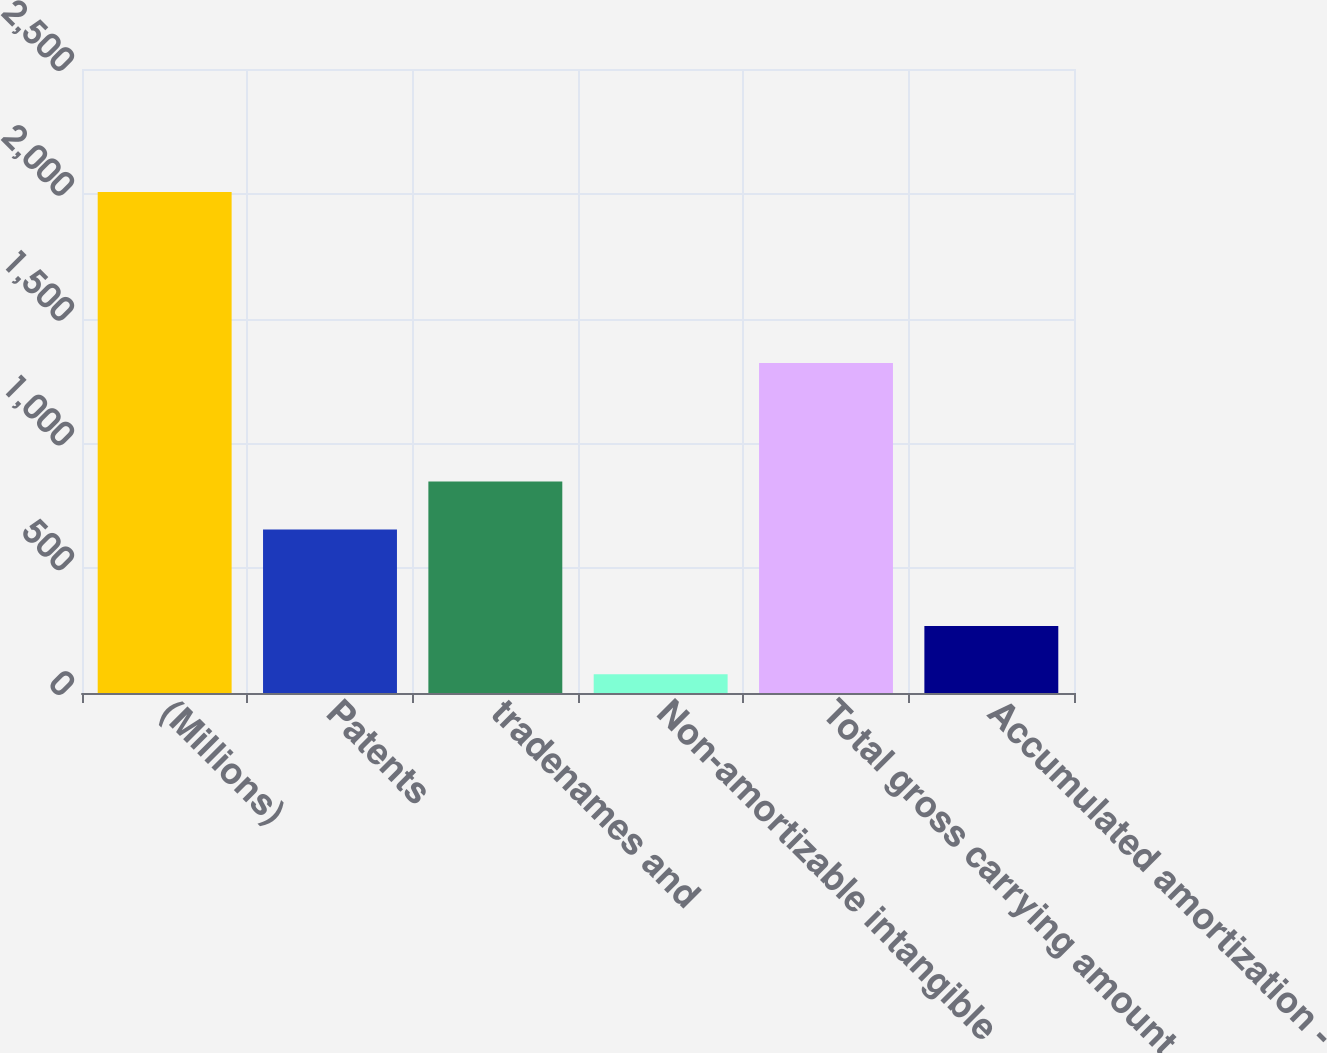Convert chart to OTSL. <chart><loc_0><loc_0><loc_500><loc_500><bar_chart><fcel>(Millions)<fcel>Patents<fcel>tradenames and<fcel>Non-amortizable intangible<fcel>Total gross carrying amount<fcel>Accumulated amortization -<nl><fcel>2007<fcel>654.6<fcel>847.8<fcel>75<fcel>1322<fcel>268.2<nl></chart> 